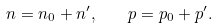<formula> <loc_0><loc_0><loc_500><loc_500>n = n _ { 0 } + n ^ { \prime } , \quad p = p _ { 0 } + p ^ { \prime } .</formula> 